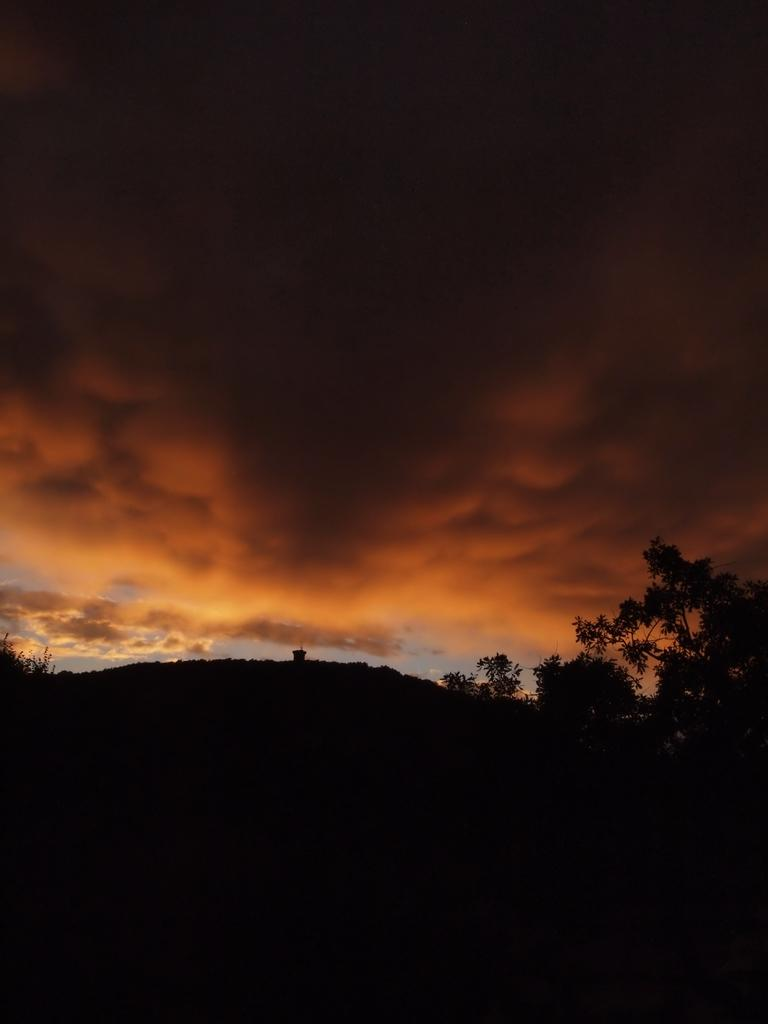What type of vegetation is on the right side of the image? There are trees on the right side of the image. What is the lighting condition at the bottom of the image? The bottom of the image appears to be dark. What can be seen in the background of the image? The sky is visible in the background of the image. How would you describe the sky in the image? The sky is cloudy. What type of jam is being spread on the edge of the branch in the image? There is no jam or branch present in the image; it features trees and a cloudy sky. 